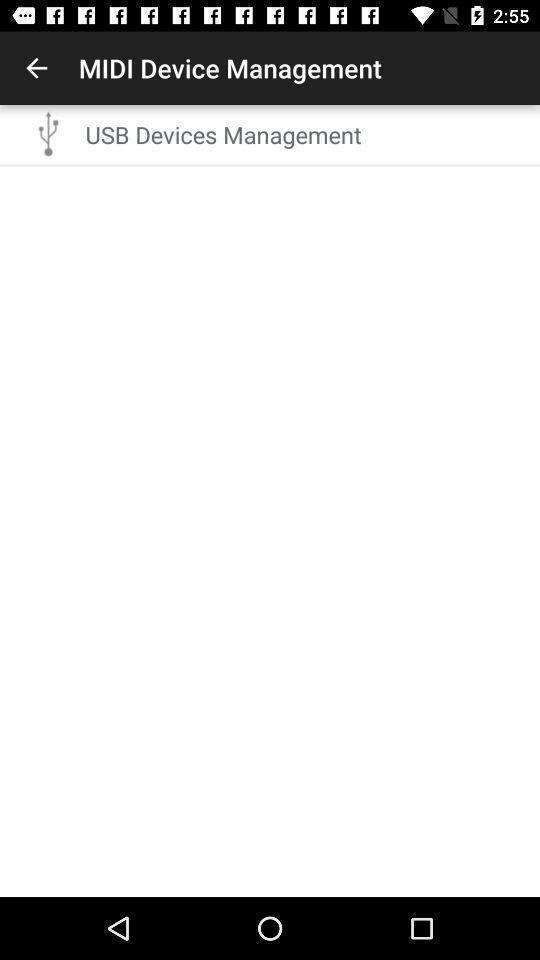What details can you identify in this image? Page displaying an option in the application. 